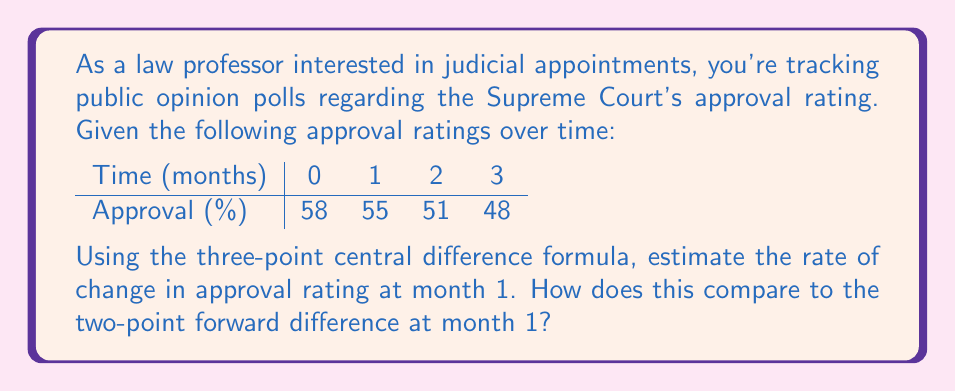Provide a solution to this math problem. Let's approach this step-by-step:

1) The three-point central difference formula is:

   $$f'(x) \approx \frac{f(x+h) - f(x-h)}{2h}$$

   where $h$ is the step size.

2) In this case, $h = 1$ month, and we're estimating at month 1.
   
   $$f'(1) \approx \frac{f(2) - f(0)}{2(1)} = \frac{51 - 58}{2} = -3.5$$

3) The two-point forward difference formula is:

   $$f'(x) \approx \frac{f(x+h) - f(x)}{h}$$

4) Using this formula at month 1:

   $$f'(1) \approx \frac{f(2) - f(1)}{1} = 51 - 55 = -4$$

5) The three-point central difference gives an estimate of -3.5% per month, while the two-point forward difference gives -4% per month.

6) The central difference is generally more accurate as it uses data from both sides of the point of interest, reducing the effect of local fluctuations.
Answer: Three-point central difference: -3.5% per month; Two-point forward difference: -4% per month 